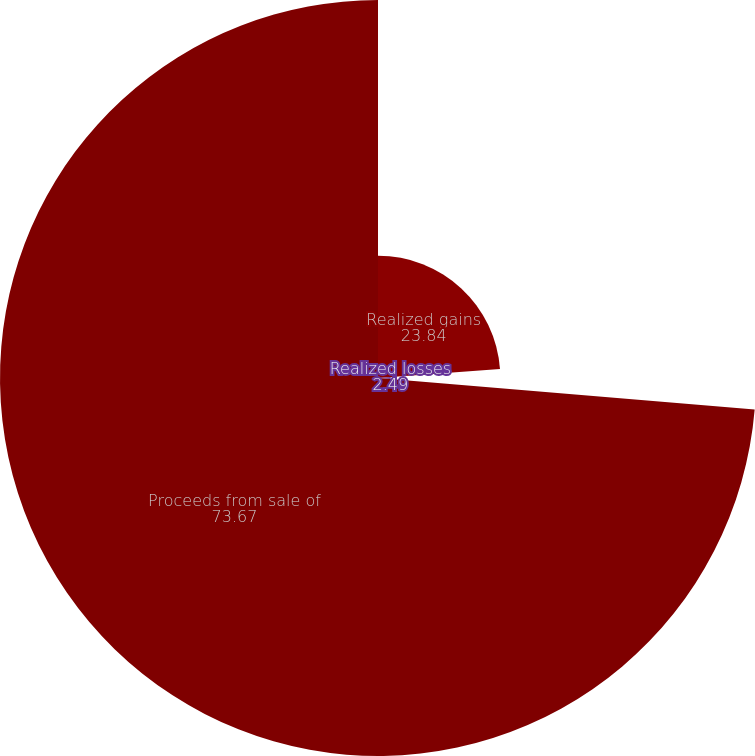Convert chart to OTSL. <chart><loc_0><loc_0><loc_500><loc_500><pie_chart><fcel>Realized gains<fcel>Realized losses<fcel>Proceeds from sale of<nl><fcel>23.84%<fcel>2.49%<fcel>73.67%<nl></chart> 